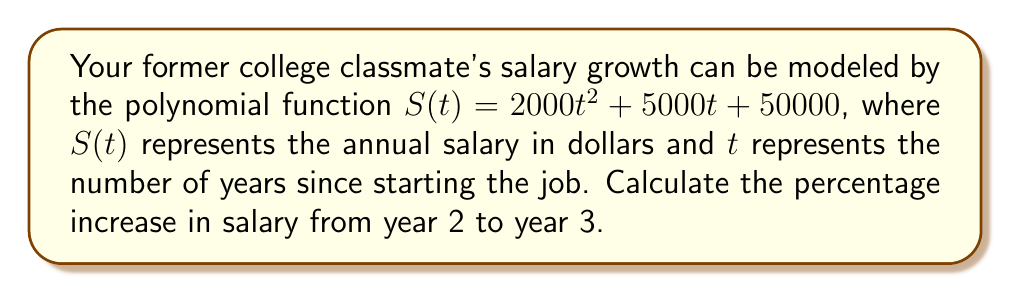Help me with this question. To solve this problem, we need to follow these steps:

1. Calculate the salary at year 2:
   $S(2) = 2000(2)^2 + 5000(2) + 50000$
   $S(2) = 2000(4) + 10000 + 50000$
   $S(2) = 8000 + 10000 + 50000 = 68000$

2. Calculate the salary at year 3:
   $S(3) = 2000(3)^2 + 5000(3) + 50000$
   $S(3) = 2000(9) + 15000 + 50000$
   $S(3) = 18000 + 15000 + 50000 = 83000$

3. Calculate the difference in salary:
   $\text{Difference} = S(3) - S(2) = 83000 - 68000 = 15000$

4. Calculate the percentage increase:
   $\text{Percentage increase} = \frac{\text{Difference}}{\text{Initial salary}} \times 100\%$
   $\text{Percentage increase} = \frac{15000}{68000} \times 100\% \approx 22.06\%$
Answer: $22.06\%$ 